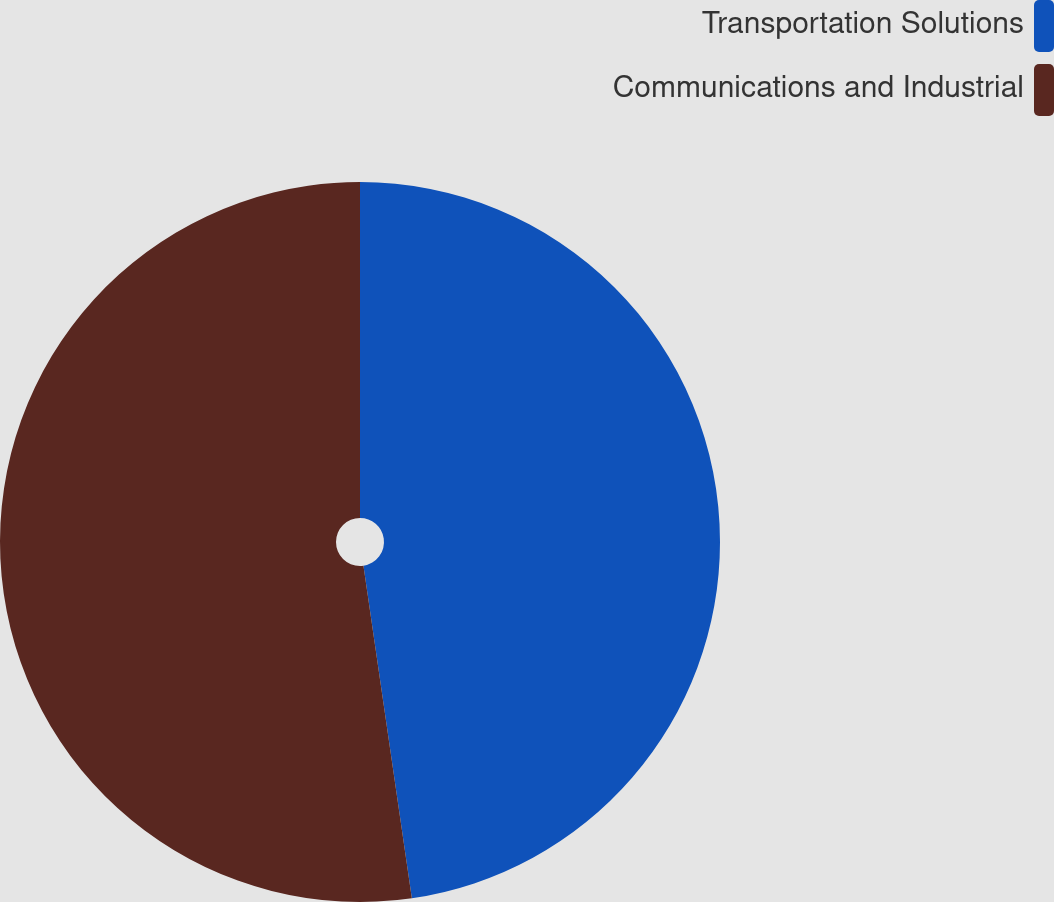Convert chart to OTSL. <chart><loc_0><loc_0><loc_500><loc_500><pie_chart><fcel>Transportation Solutions<fcel>Communications and Industrial<nl><fcel>47.7%<fcel>52.3%<nl></chart> 